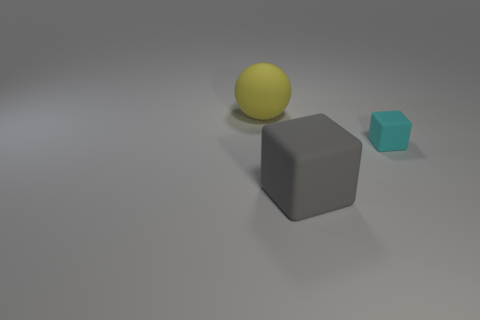How many objects are large red shiny spheres or large gray matte cubes?
Your response must be concise. 1. Are any big yellow metallic objects visible?
Provide a short and direct response. No. What shape is the large thing that is right of the big object behind the cyan rubber object?
Offer a very short reply. Cube. What number of objects are rubber things left of the gray object or large things that are behind the small matte thing?
Offer a terse response. 1. There is a object that is the same size as the gray matte cube; what is its material?
Your answer should be very brief. Rubber. The ball has what color?
Keep it short and to the point. Yellow. There is a object that is behind the big gray matte object and in front of the big yellow ball; what material is it?
Your answer should be very brief. Rubber. There is a large rubber thing that is behind the big thing that is in front of the tiny cyan thing; is there a matte ball right of it?
Give a very brief answer. No. Are there any balls left of the cyan cube?
Give a very brief answer. Yes. What number of other objects are there of the same shape as the cyan object?
Provide a short and direct response. 1. 